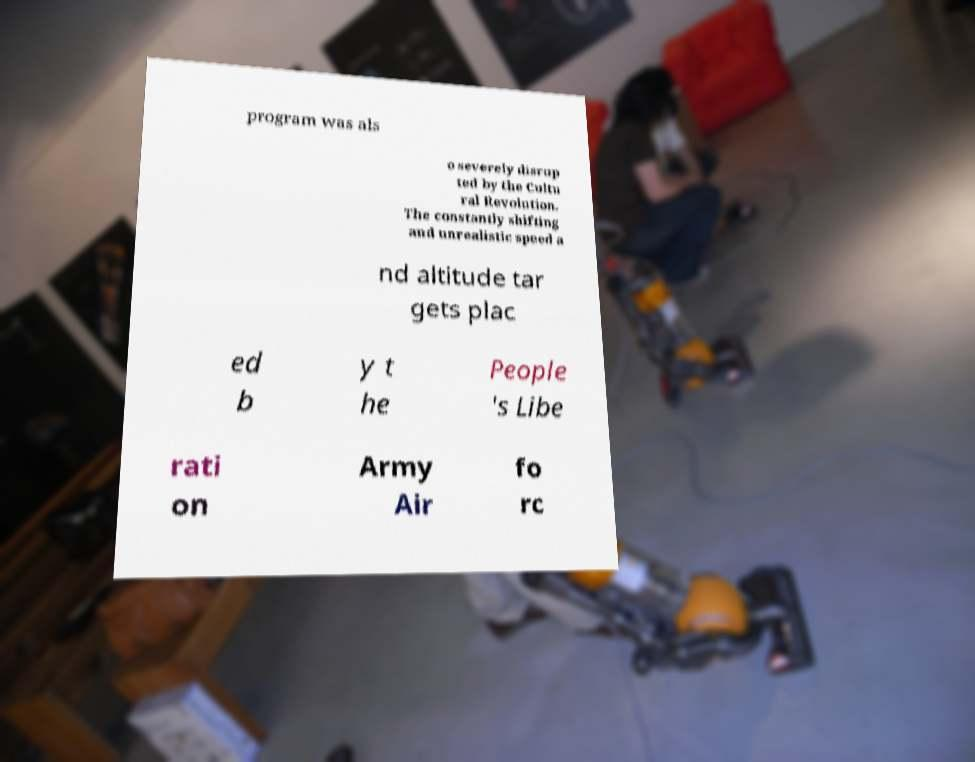What messages or text are displayed in this image? I need them in a readable, typed format. program was als o severely disrup ted by the Cultu ral Revolution. The constantly shifting and unrealistic speed a nd altitude tar gets plac ed b y t he People 's Libe rati on Army Air fo rc 